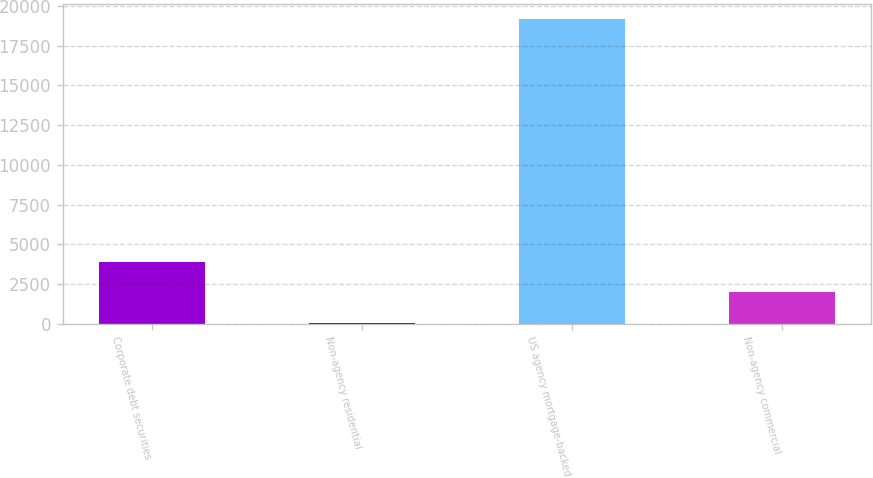Convert chart to OTSL. <chart><loc_0><loc_0><loc_500><loc_500><bar_chart><fcel>Corporate debt securities<fcel>Non-agency residential<fcel>US agency mortgage-backed<fcel>Non-agency commercial<nl><fcel>3906.2<fcel>89<fcel>19175<fcel>1997.6<nl></chart> 